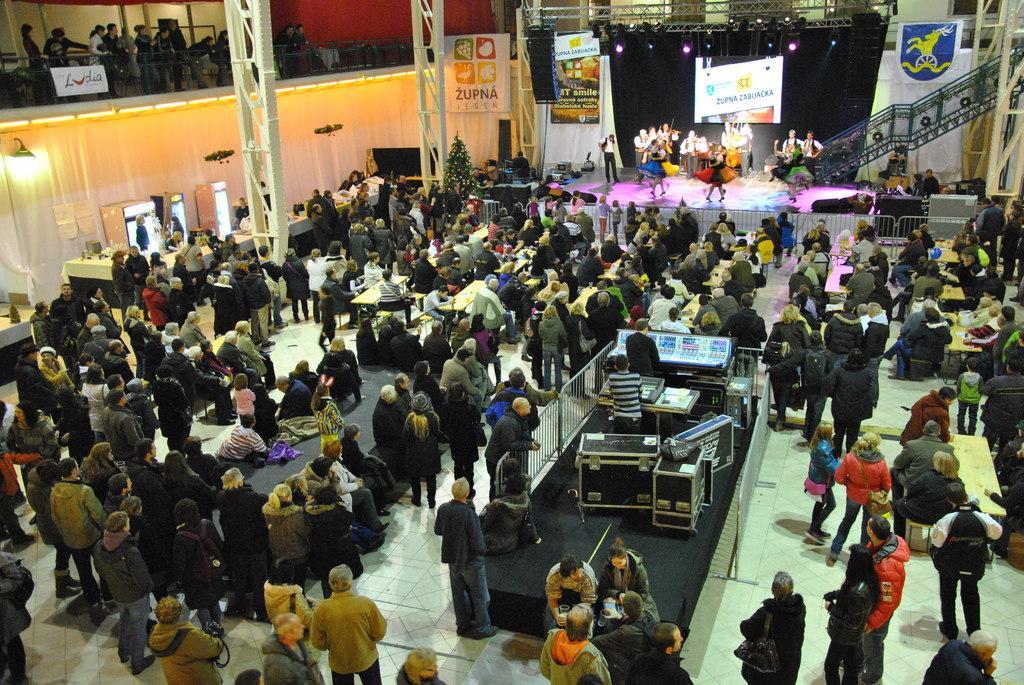Could you give a brief overview of what you see in this image? This picture describes about group of people, few are standing, few are sitting and few people playing musical instruments, in the background we can see hoardings. few lights and metal rods, on the left side of the image we can see curtains. 